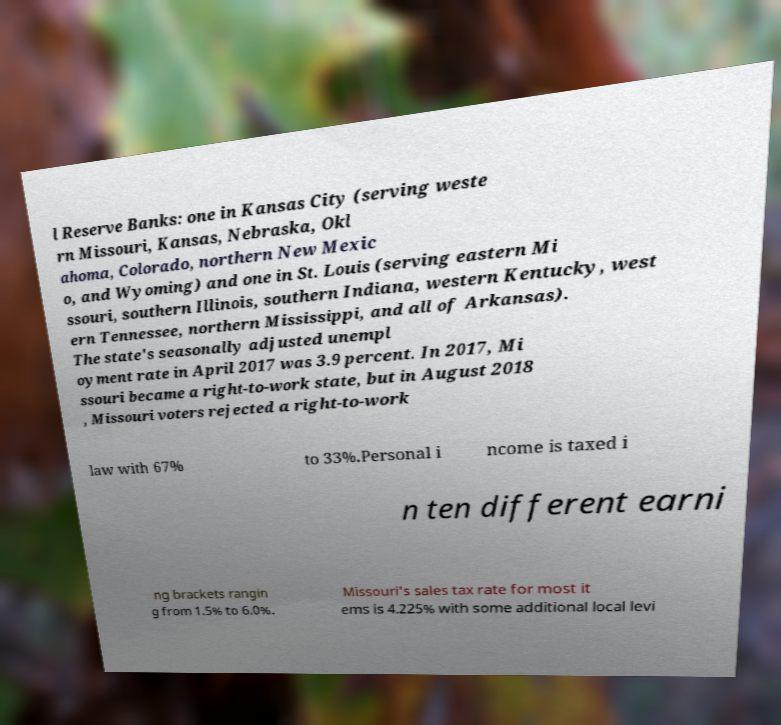Please identify and transcribe the text found in this image. l Reserve Banks: one in Kansas City (serving weste rn Missouri, Kansas, Nebraska, Okl ahoma, Colorado, northern New Mexic o, and Wyoming) and one in St. Louis (serving eastern Mi ssouri, southern Illinois, southern Indiana, western Kentucky, west ern Tennessee, northern Mississippi, and all of Arkansas). The state's seasonally adjusted unempl oyment rate in April 2017 was 3.9 percent. In 2017, Mi ssouri became a right-to-work state, but in August 2018 , Missouri voters rejected a right-to-work law with 67% to 33%.Personal i ncome is taxed i n ten different earni ng brackets rangin g from 1.5% to 6.0%. Missouri's sales tax rate for most it ems is 4.225% with some additional local levi 